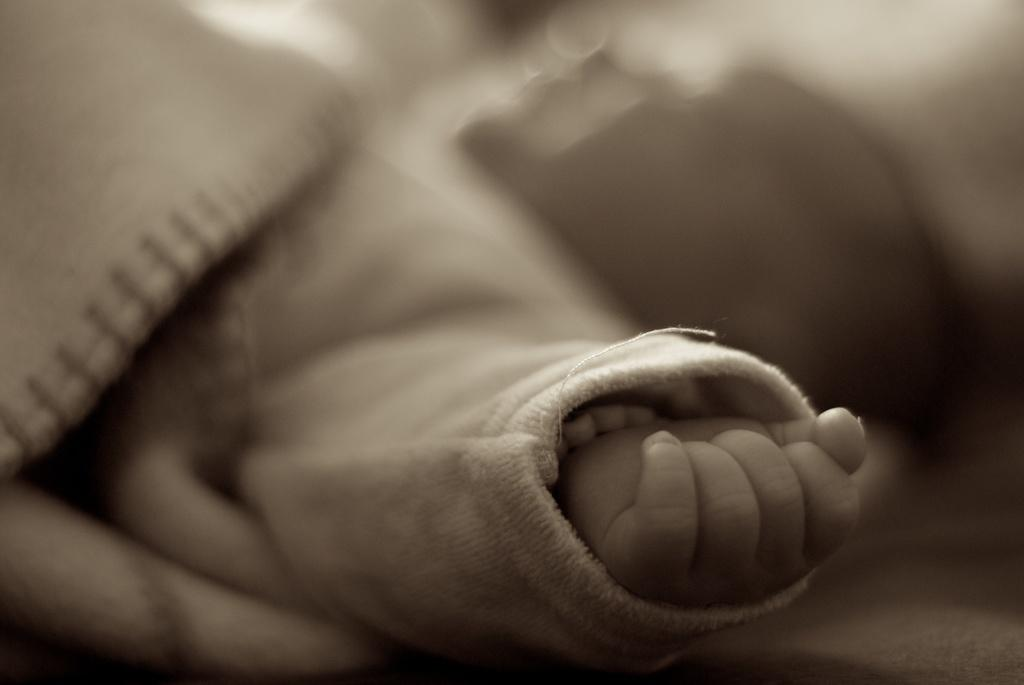What is the main subject of the image? The main subject of the image is the hand of a kid. Can you describe the background of the image? The background of the image is blurred. What type of beast can be seen in the background of the image? There is no beast present in the image; the background is blurred. What type of grain is visible in the image? There is no grain present in the image; it only features the hand of a kid and a blurred background. 